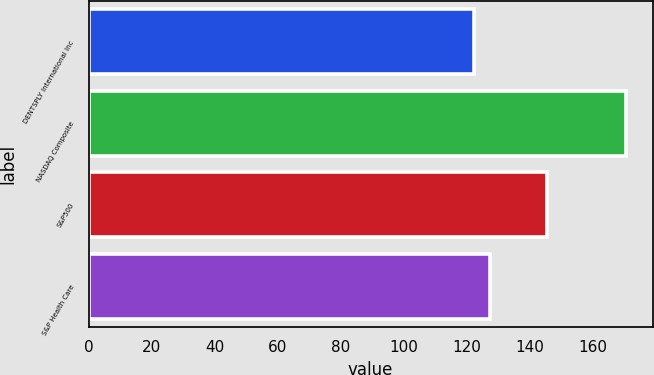Convert chart to OTSL. <chart><loc_0><loc_0><loc_500><loc_500><bar_chart><fcel>DENTSPLY International Inc<fcel>NASDAQ Composite<fcel>S&P500<fcel>S&P Health Care<nl><fcel>122.53<fcel>170.58<fcel>145.51<fcel>127.34<nl></chart> 